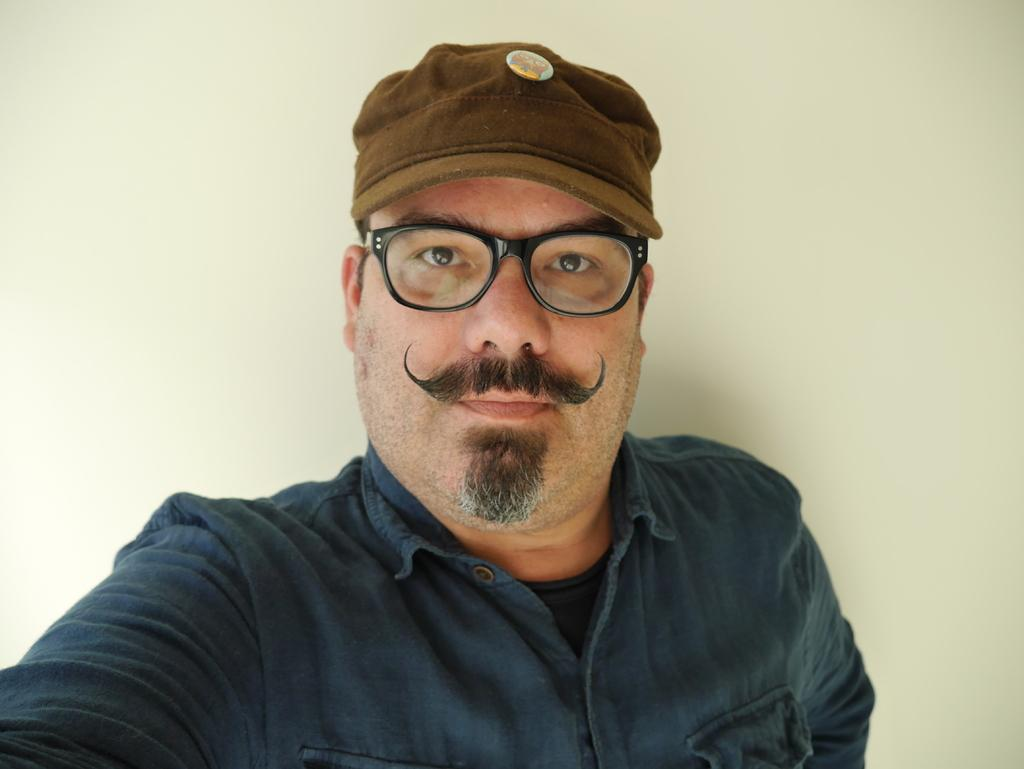Who is present in the image? There is a man in the image. What accessories is the man wearing? The man is wearing spectacles and a cap. What can be seen in the background of the image? There is a wall in the background of the image. What type of pipe is the man smoking in the image? There is no pipe present in the image; the man is not smoking. 